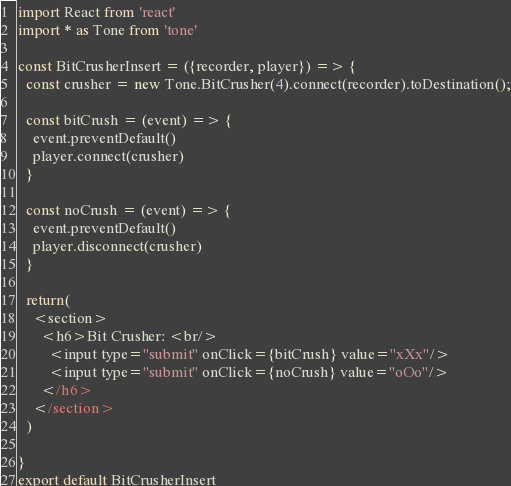<code> <loc_0><loc_0><loc_500><loc_500><_JavaScript_>import React from 'react'
import * as Tone from 'tone'

const BitCrusherInsert = ({recorder, player}) => {
  const crusher = new Tone.BitCrusher(4).connect(recorder).toDestination();

  const bitCrush = (event) => {
    event.preventDefault()
    player.connect(crusher)
  }

  const noCrush = (event) => {
    event.preventDefault()
    player.disconnect(crusher)
  }

  return(
    <section>
      <h6>Bit Crusher: <br/>
        <input type="submit" onClick={bitCrush} value="xXx"/>
        <input type="submit" onClick={noCrush} value="oOo"/>
      </h6>
    </section>
  )

}
export default BitCrusherInsert</code> 